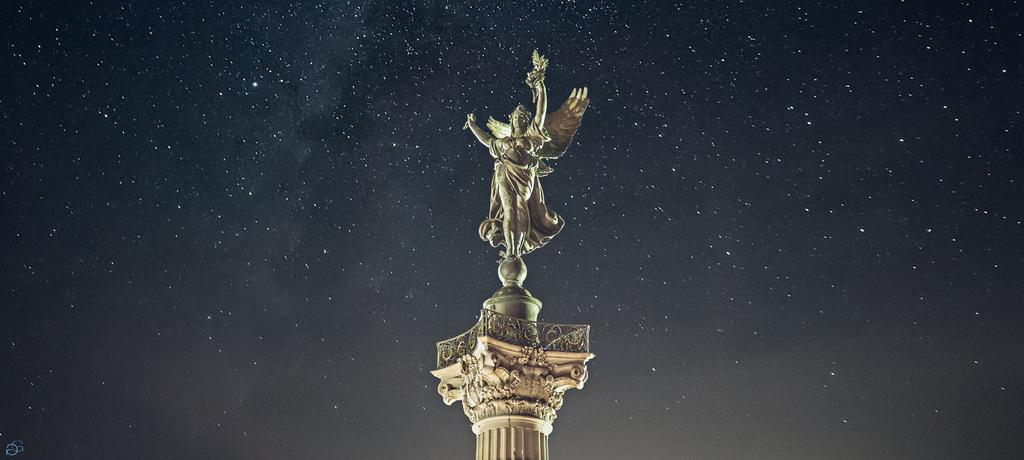What is the main subject in the middle of the image? There is a statue in the middle of the image. What can be seen in the background of the image? Stars are visible in the sky in the background of the image. What direction is the pickle facing in the image? There is no pickle present in the image, so it cannot be determined which direction it might be facing. 